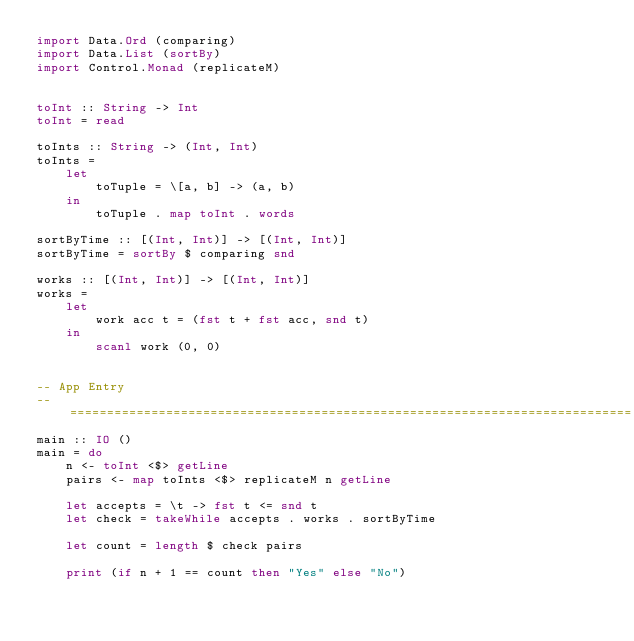<code> <loc_0><loc_0><loc_500><loc_500><_Haskell_>import Data.Ord (comparing)
import Data.List (sortBy)
import Control.Monad (replicateM)


toInt :: String -> Int
toInt = read

toInts :: String -> (Int, Int)
toInts =
    let
        toTuple = \[a, b] -> (a, b)
    in
        toTuple . map toInt . words

sortByTime :: [(Int, Int)] -> [(Int, Int)]
sortByTime = sortBy $ comparing snd

works :: [(Int, Int)] -> [(Int, Int)]
works = 
    let
        work acc t = (fst t + fst acc, snd t)
    in
        scanl work (0, 0)


-- App Entry
-- ============================================================================
main :: IO ()
main = do
    n <- toInt <$> getLine
    pairs <- map toInts <$> replicateM n getLine

    let accepts = \t -> fst t <= snd t
    let check = takeWhile accepts . works . sortByTime

    let count = length $ check pairs

    print (if n + 1 == count then "Yes" else "No")</code> 